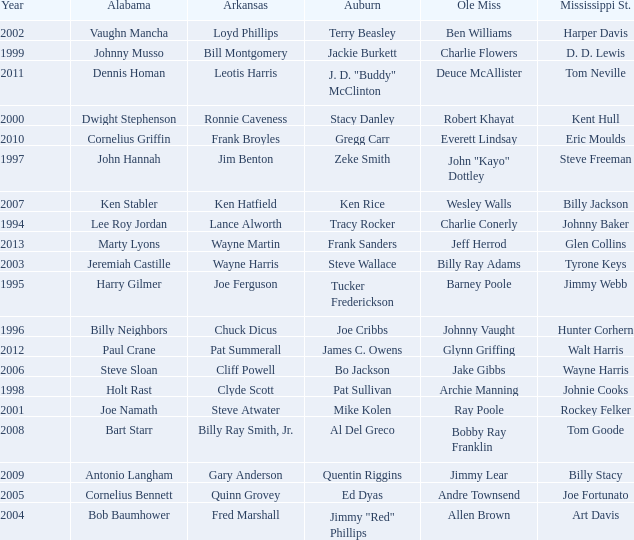Parse the full table. {'header': ['Year', 'Alabama', 'Arkansas', 'Auburn', 'Ole Miss', 'Mississippi St.'], 'rows': [['2002', 'Vaughn Mancha', 'Loyd Phillips', 'Terry Beasley', 'Ben Williams', 'Harper Davis'], ['1999', 'Johnny Musso', 'Bill Montgomery', 'Jackie Burkett', 'Charlie Flowers', 'D. D. Lewis'], ['2011', 'Dennis Homan', 'Leotis Harris', 'J. D. "Buddy" McClinton', 'Deuce McAllister', 'Tom Neville'], ['2000', 'Dwight Stephenson', 'Ronnie Caveness', 'Stacy Danley', 'Robert Khayat', 'Kent Hull'], ['2010', 'Cornelius Griffin', 'Frank Broyles', 'Gregg Carr', 'Everett Lindsay', 'Eric Moulds'], ['1997', 'John Hannah', 'Jim Benton', 'Zeke Smith', 'John "Kayo" Dottley', 'Steve Freeman'], ['2007', 'Ken Stabler', 'Ken Hatfield', 'Ken Rice', 'Wesley Walls', 'Billy Jackson'], ['1994', 'Lee Roy Jordan', 'Lance Alworth', 'Tracy Rocker', 'Charlie Conerly', 'Johnny Baker'], ['2013', 'Marty Lyons', 'Wayne Martin', 'Frank Sanders', 'Jeff Herrod', 'Glen Collins'], ['2003', 'Jeremiah Castille', 'Wayne Harris', 'Steve Wallace', 'Billy Ray Adams', 'Tyrone Keys'], ['1995', 'Harry Gilmer', 'Joe Ferguson', 'Tucker Frederickson', 'Barney Poole', 'Jimmy Webb'], ['1996', 'Billy Neighbors', 'Chuck Dicus', 'Joe Cribbs', 'Johnny Vaught', 'Hunter Corhern'], ['2012', 'Paul Crane', 'Pat Summerall', 'James C. Owens', 'Glynn Griffing', 'Walt Harris'], ['2006', 'Steve Sloan', 'Cliff Powell', 'Bo Jackson', 'Jake Gibbs', 'Wayne Harris'], ['1998', 'Holt Rast', 'Clyde Scott', 'Pat Sullivan', 'Archie Manning', 'Johnie Cooks'], ['2001', 'Joe Namath', 'Steve Atwater', 'Mike Kolen', 'Ray Poole', 'Rockey Felker'], ['2008', 'Bart Starr', 'Billy Ray Smith, Jr.', 'Al Del Greco', 'Bobby Ray Franklin', 'Tom Goode'], ['2009', 'Antonio Langham', 'Gary Anderson', 'Quentin Riggins', 'Jimmy Lear', 'Billy Stacy'], ['2005', 'Cornelius Bennett', 'Quinn Grovey', 'Ed Dyas', 'Andre Townsend', 'Joe Fortunato'], ['2004', 'Bob Baumhower', 'Fred Marshall', 'Jimmy "Red" Phillips', 'Allen Brown', 'Art Davis']]} Who is the Arkansas player associated with Ken Stabler? Ken Hatfield. 